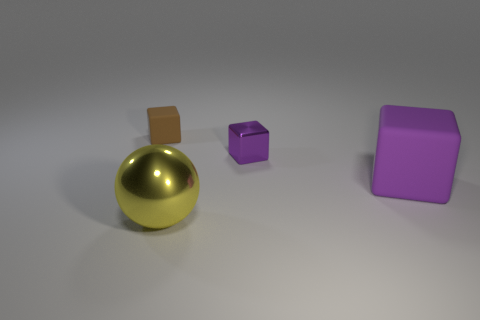Subtract all purple cubes. How many cubes are left? 1 Subtract all purple cylinders. How many purple blocks are left? 2 Add 1 tiny brown cylinders. How many objects exist? 5 Subtract all spheres. How many objects are left? 3 Subtract all cyan blocks. Subtract all purple cylinders. How many blocks are left? 3 Subtract all blue matte spheres. Subtract all big rubber objects. How many objects are left? 3 Add 3 small metal objects. How many small metal objects are left? 4 Add 1 large purple rubber blocks. How many large purple rubber blocks exist? 2 Subtract 0 red blocks. How many objects are left? 4 